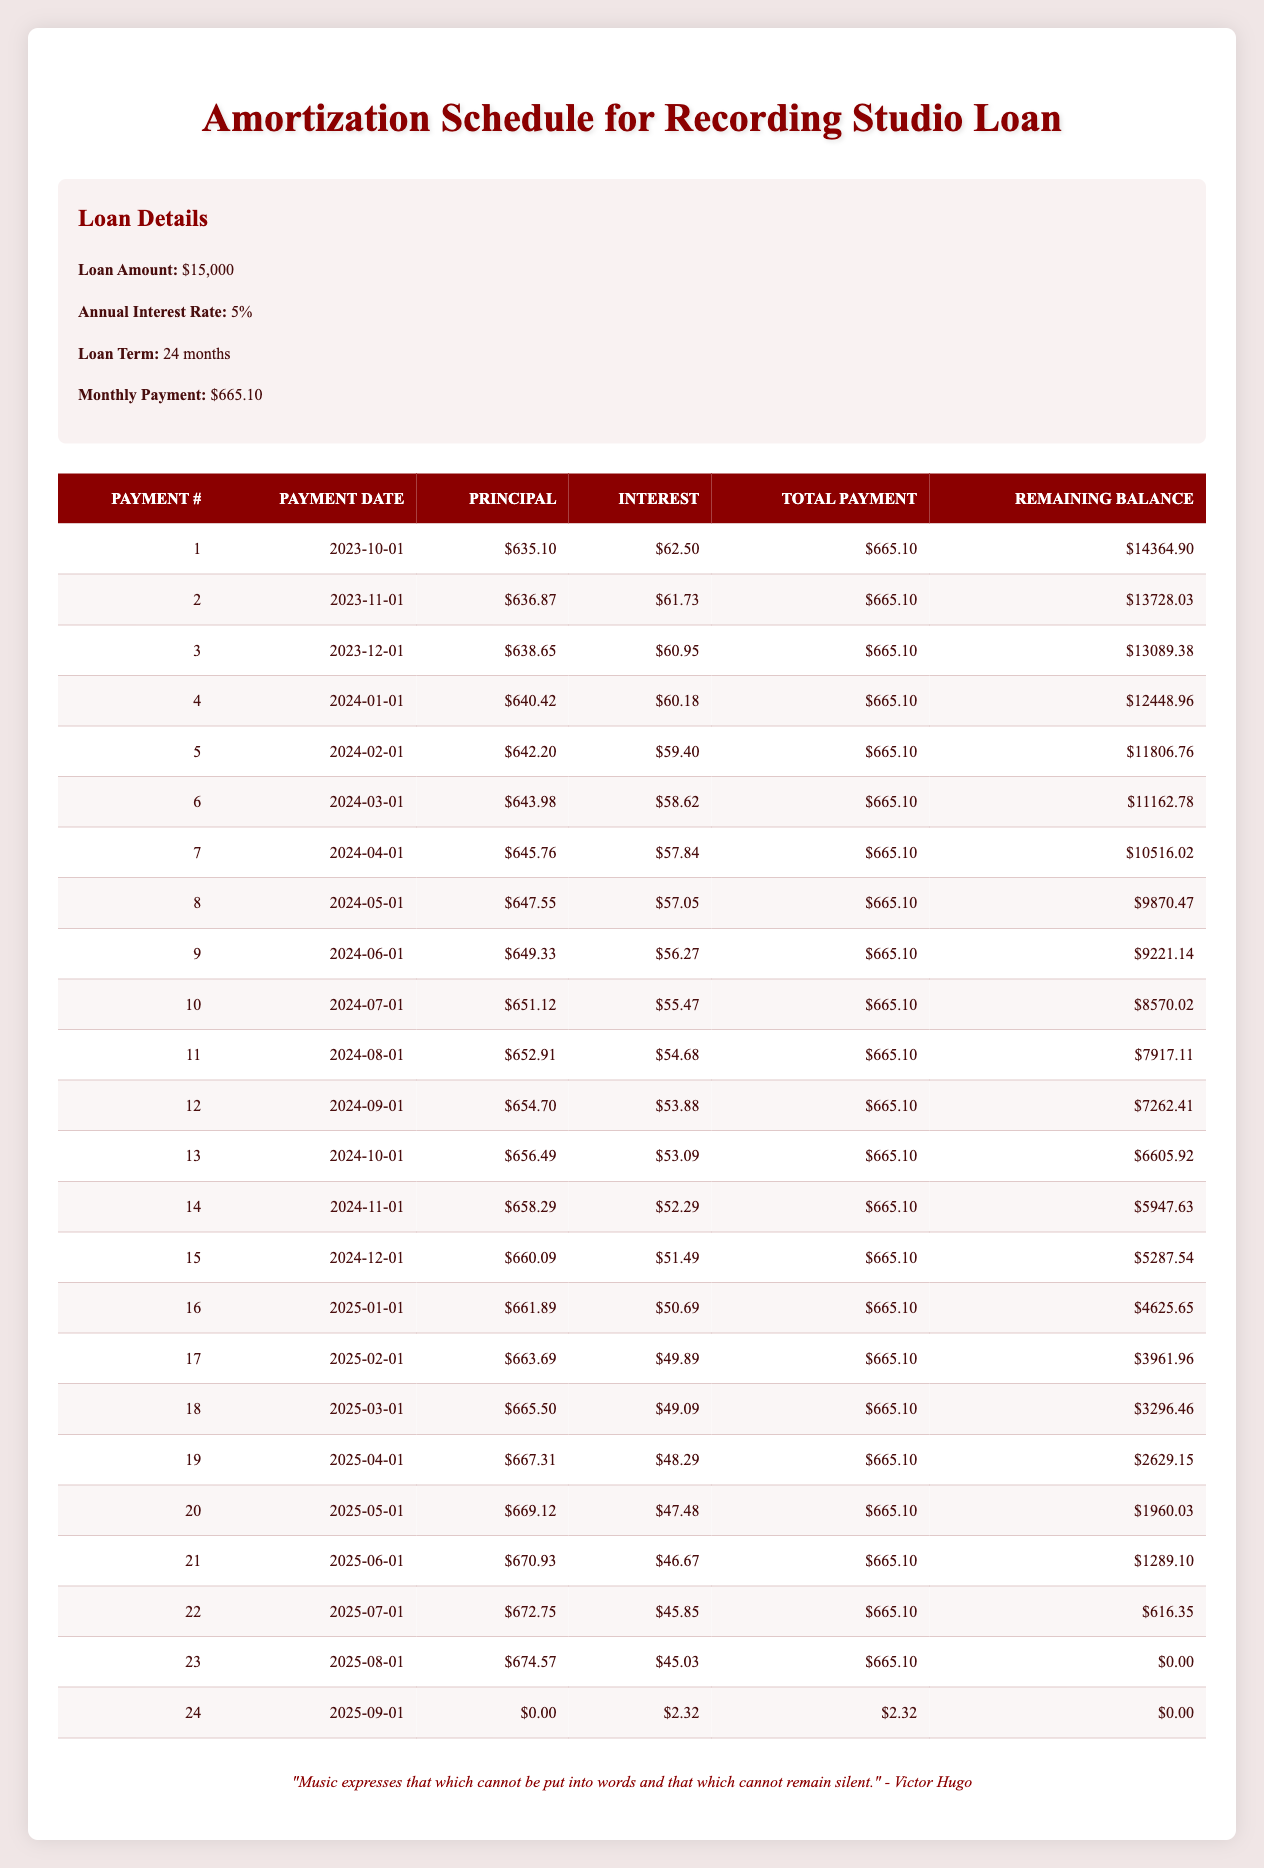What is the total loan amount taken for recording studio expenses? The total loan amount mentioned in the loan details section is $15,000.
Answer: $15,000 What was the principal payment for the first month? In the first payment row, the principal payment is listed as $635.10.
Answer: $635.10 How much total payment is made each month? Each month, the total payment is consistently $665.10 as stated in the loan details and visible in each row of the table.
Answer: $665.10 What is the remaining balance after the first payment? After the first payment, the remaining balance is observed as $14,364.90.
Answer: $14,364.90 How much interest was paid in the second month? The interest payment for the second month, as stated in the table, is $61.73.
Answer: $61.73 What is the total amount paid in principal after the first three payments? The principal payments for the first three months are $635.10, $636.87, and $638.65. Adding these gives $635.10 + $636.87 + $638.65 = $1910.62.
Answer: $1910.62 Is there any month where the principal payment was zero? The table shows that in the 24th month, the principal payment is indeed zero, while interest is paid.
Answer: Yes What is the average interest payment over the life of the loan? The interest payments for the 24 months need to be summed, and then divided by 24. Totaling the interest gives $1,177.65 (calculated from the table). Dividing by 24 gives $1,177.65 / 24 = $49.90 (rounded).
Answer: $49.90 Which payment number has the highest principal payment and what is it? By reviewing the principal payments listed, the highest payment is $674.57, occurring in payment number 23.
Answer: Payment number 23, $674.57 What is the difference between the total payments made in month 10 and month 20? The total payments for both months are $665.10 each. So, the difference is $665.10 - $665.10 = $0.
Answer: $0 